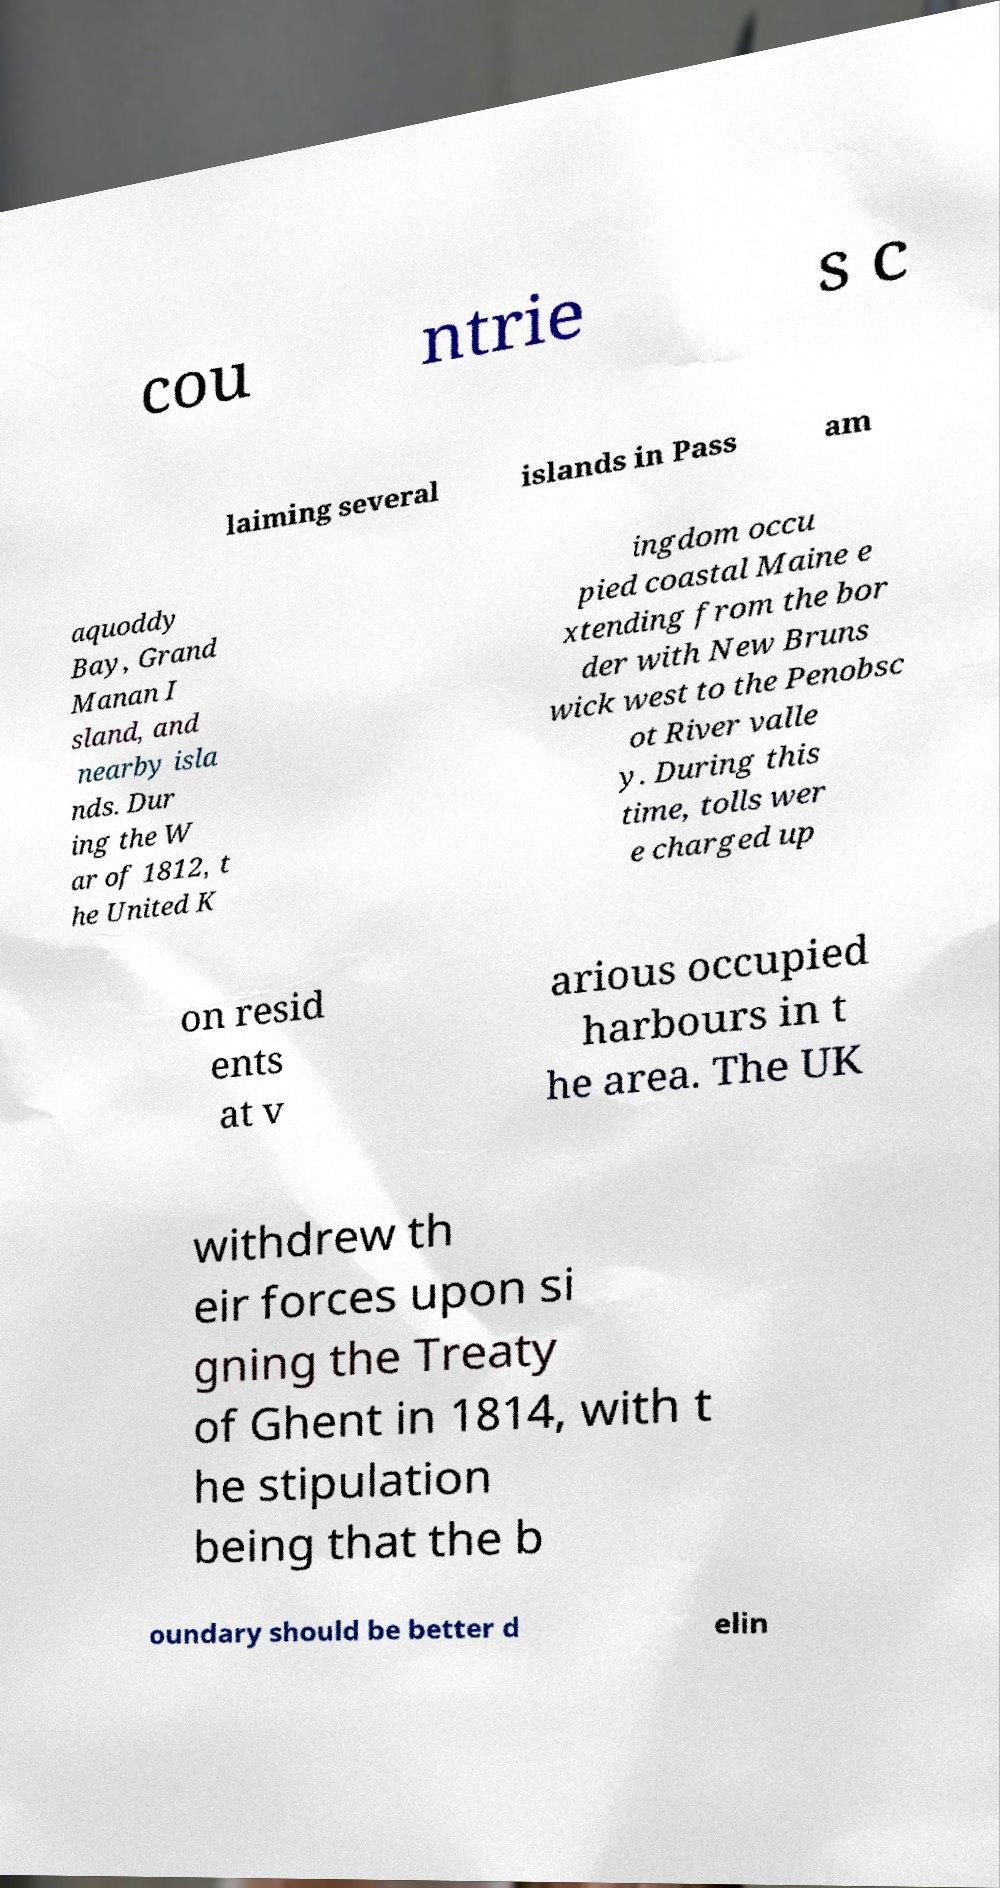Please identify and transcribe the text found in this image. cou ntrie s c laiming several islands in Pass am aquoddy Bay, Grand Manan I sland, and nearby isla nds. Dur ing the W ar of 1812, t he United K ingdom occu pied coastal Maine e xtending from the bor der with New Bruns wick west to the Penobsc ot River valle y. During this time, tolls wer e charged up on resid ents at v arious occupied harbours in t he area. The UK withdrew th eir forces upon si gning the Treaty of Ghent in 1814, with t he stipulation being that the b oundary should be better d elin 